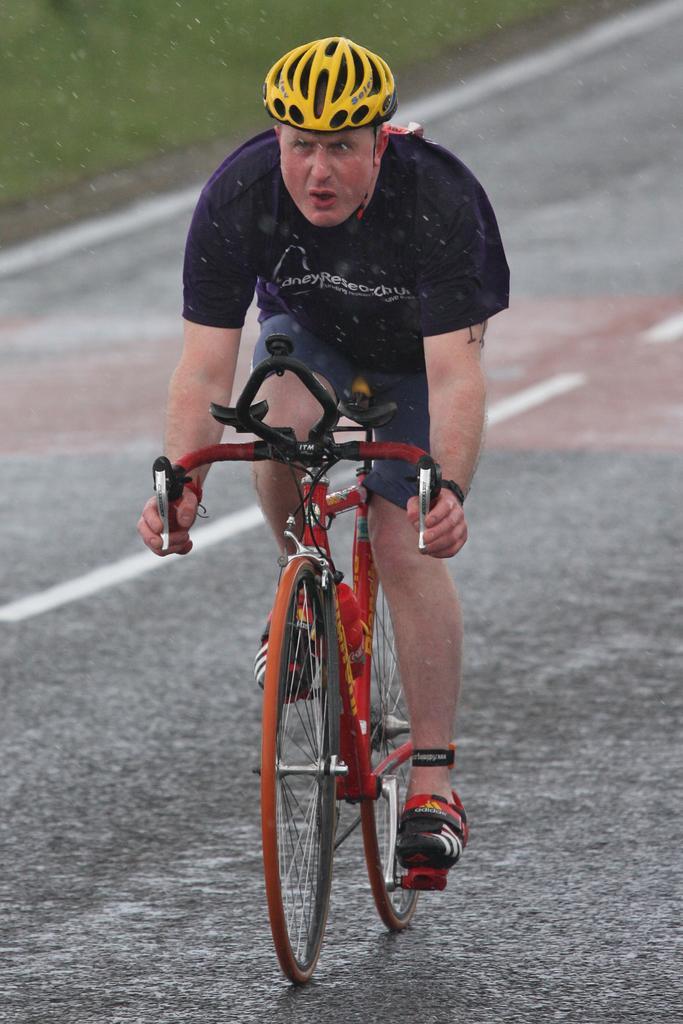In one or two sentences, can you explain what this image depicts? In the picture there is a person riding bicycle on the road, he is wearing a helmet. 